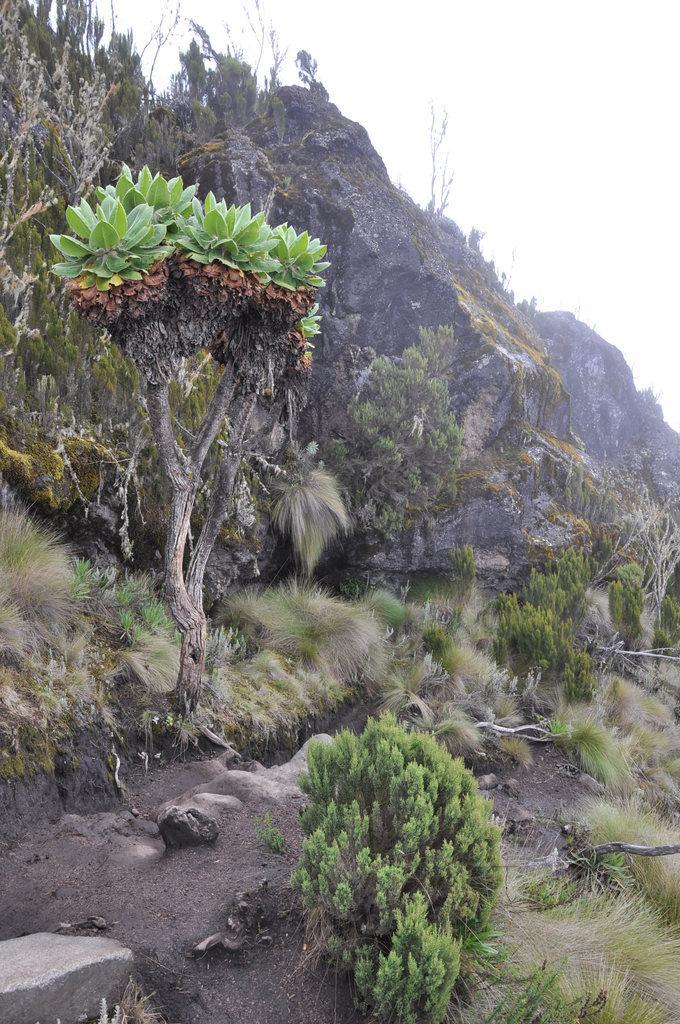Could you give a brief overview of what you see in this image? In this image, I can see the trees, plants and grass on a hill. In the background, there is the sky. 